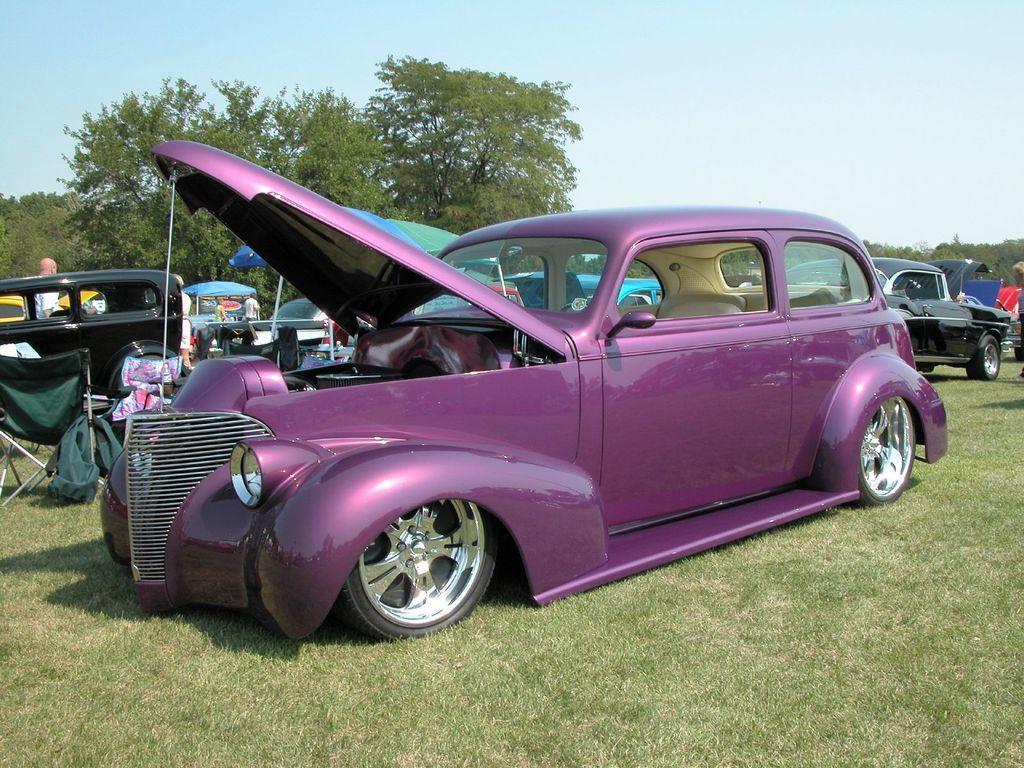Describe this image in one or two sentences. In this image we can see vehicles, umbrellas, people, grass, trees, and few objects. In the background there is sky. 